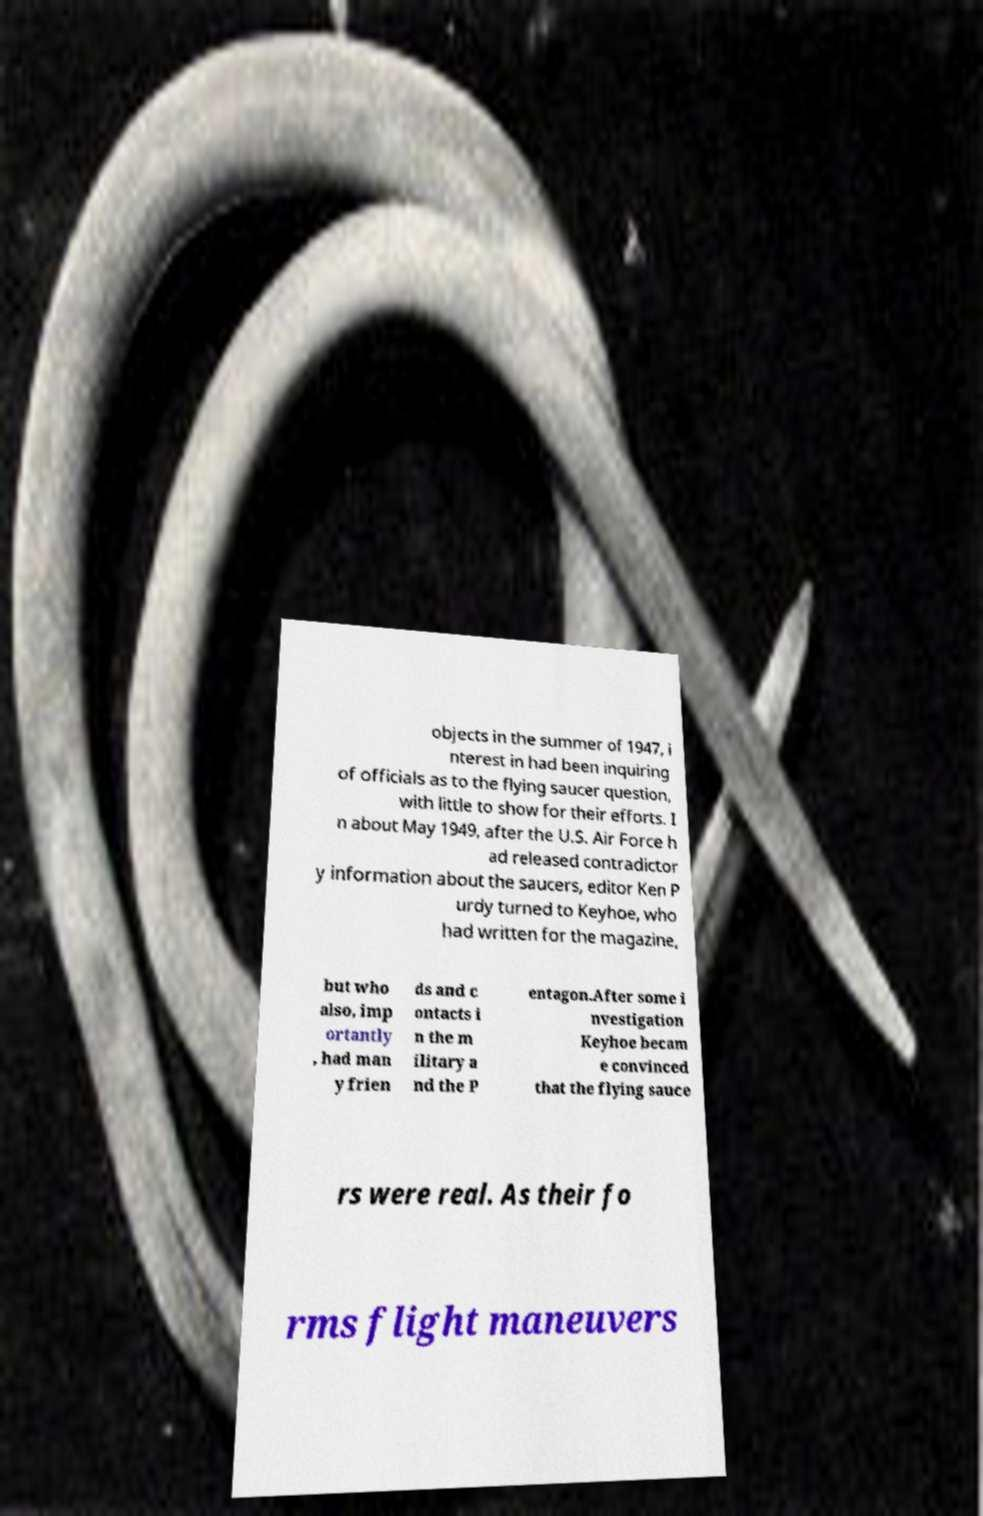I need the written content from this picture converted into text. Can you do that? objects in the summer of 1947, i nterest in had been inquiring of officials as to the flying saucer question, with little to show for their efforts. I n about May 1949, after the U.S. Air Force h ad released contradictor y information about the saucers, editor Ken P urdy turned to Keyhoe, who had written for the magazine, but who also, imp ortantly , had man y frien ds and c ontacts i n the m ilitary a nd the P entagon.After some i nvestigation Keyhoe becam e convinced that the flying sauce rs were real. As their fo rms flight maneuvers 